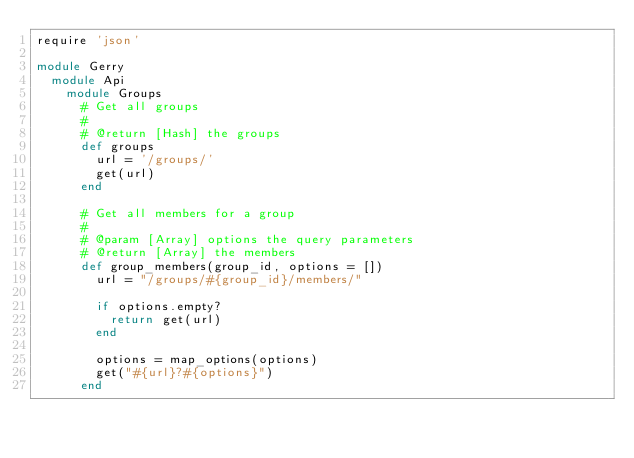<code> <loc_0><loc_0><loc_500><loc_500><_Ruby_>require 'json'

module Gerry
  module Api
    module Groups
      # Get all groups
      #
      # @return [Hash] the groups
      def groups
        url = '/groups/'
        get(url)
      end

      # Get all members for a group
      #
      # @param [Array] options the query parameters
      # @return [Array] the members
      def group_members(group_id, options = [])
        url = "/groups/#{group_id}/members/"

        if options.empty?
          return get(url)
        end

        options = map_options(options)
        get("#{url}?#{options}")
      end
</code> 